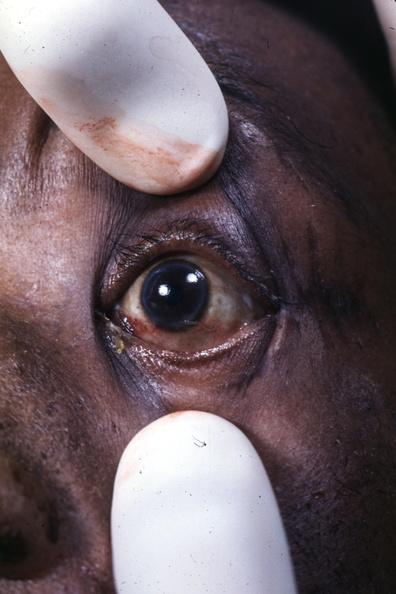what is present?
Answer the question using a single word or phrase. Arcus senilis 